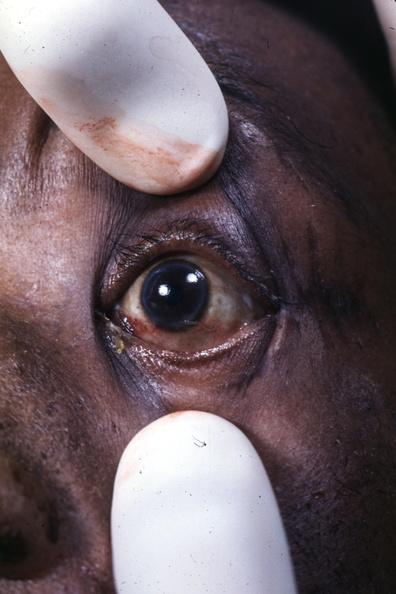what is present?
Answer the question using a single word or phrase. Arcus senilis 